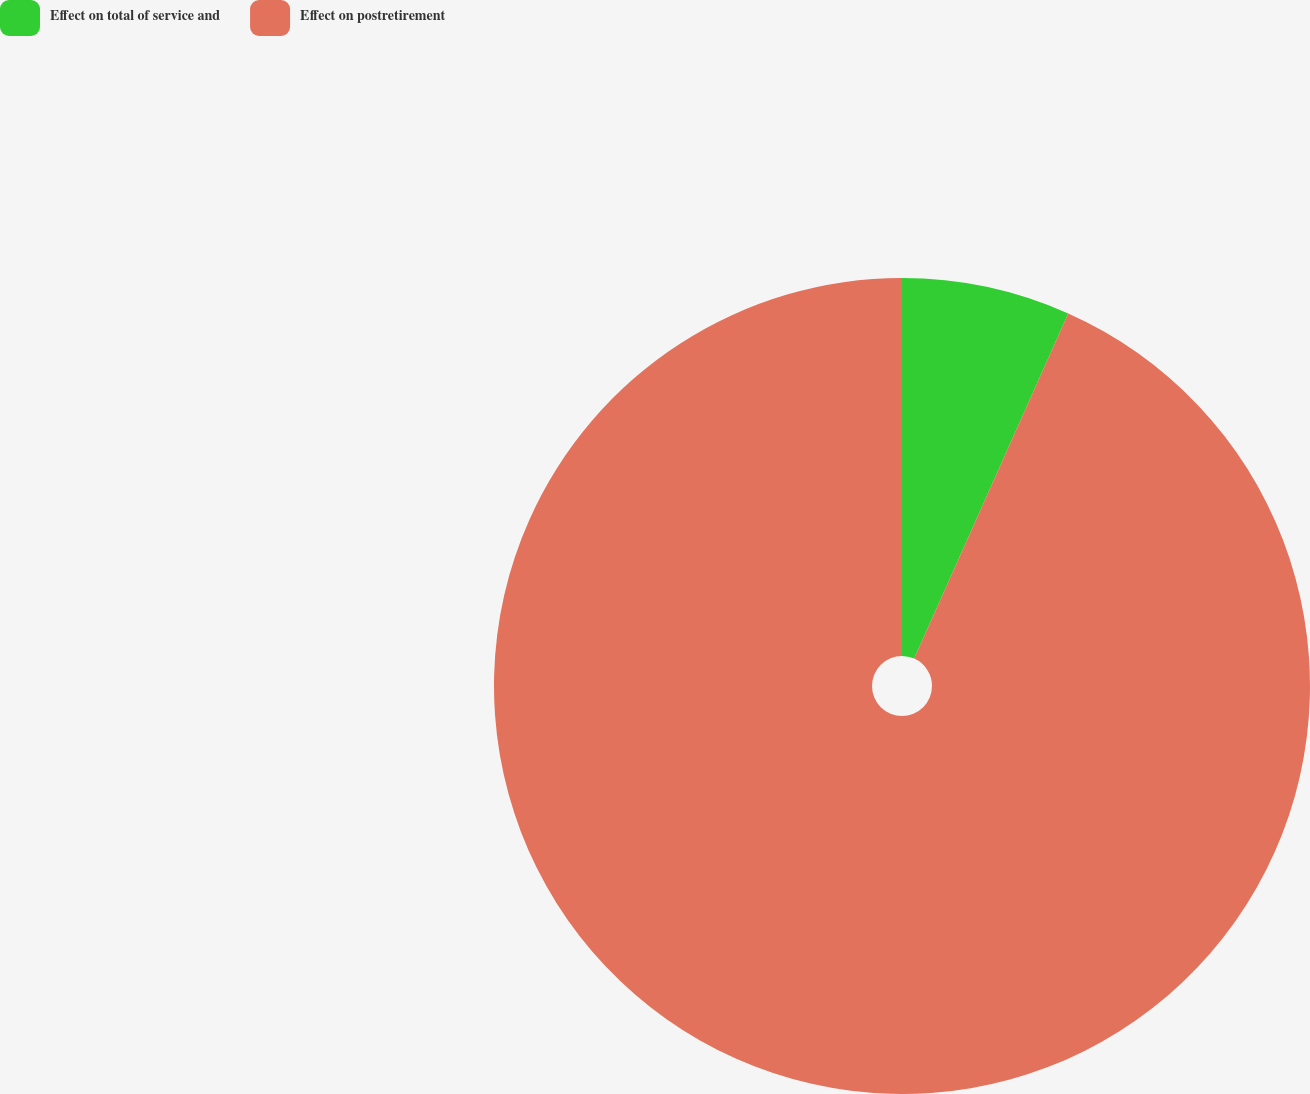Convert chart. <chart><loc_0><loc_0><loc_500><loc_500><pie_chart><fcel>Effect on total of service and<fcel>Effect on postretirement<nl><fcel>6.68%<fcel>93.32%<nl></chart> 